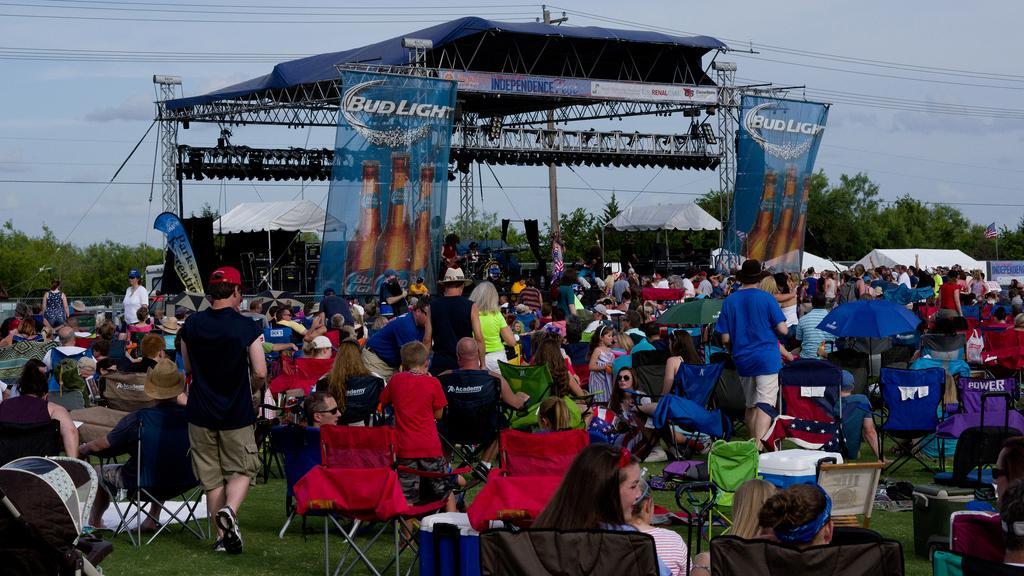Can you describe this image briefly? In this image I can see there are so many people standing and sitting on the grass ground, beside them there is a stage where we can see so many banners, also there are tents and trees at back. 